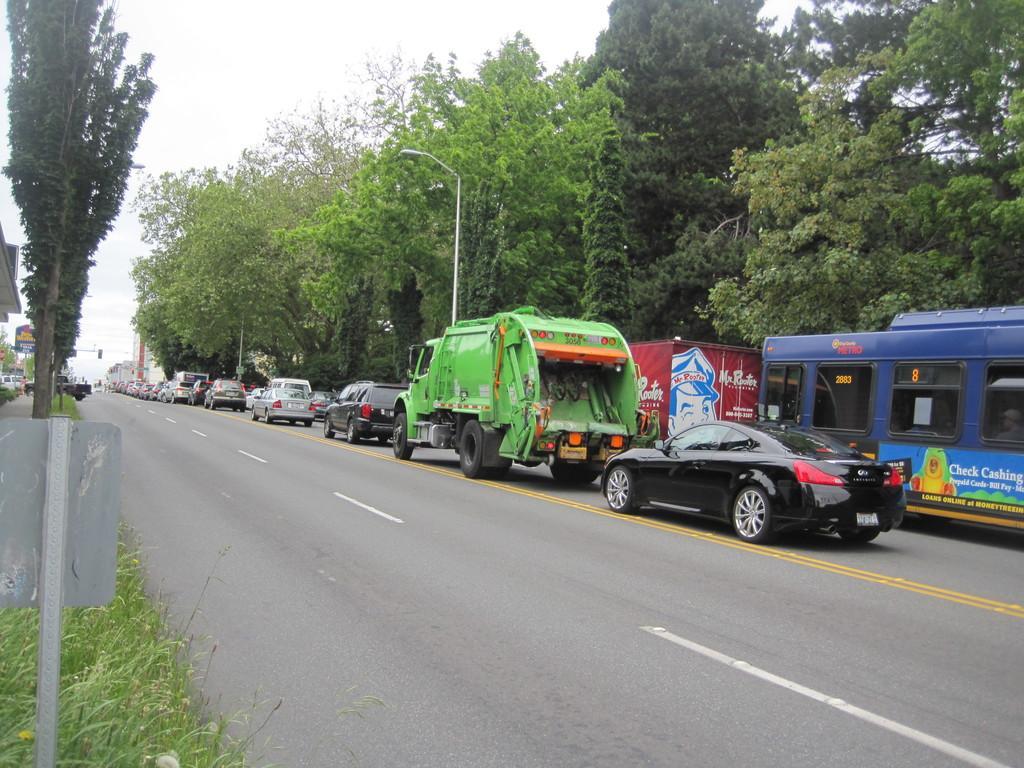Describe this image in one or two sentences. In this image I can see a road and on it I can see white lines, yellow lines and number of vehicles. I can also see number of trees, few poles, a street light, a board and on it I can see something is written. 